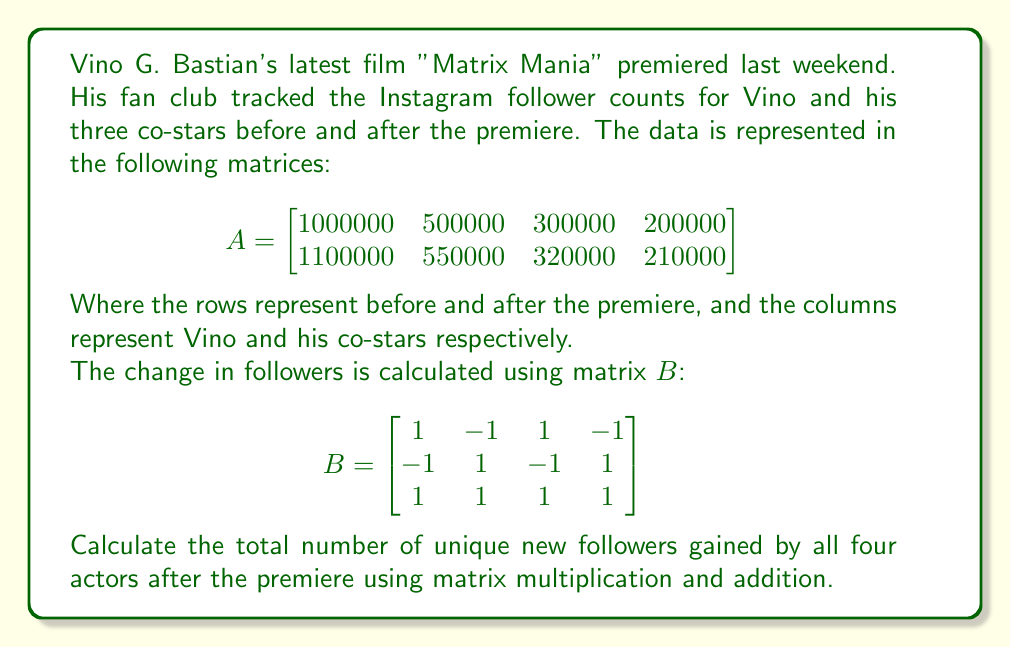Give your solution to this math problem. To solve this problem, we need to follow these steps:

1) First, we need to calculate the change in followers for each actor. We can do this by subtracting the "before" row from the "after" row in matrix $A$:

   $$C = \begin{bmatrix}
   1100000 - 1000000 & 550000 - 500000 & 320000 - 300000 & 210000 - 200000
   \end{bmatrix}$$

   $$C = \begin{bmatrix}
   100000 & 50000 & 20000 & 10000
   \end{bmatrix}$$

2) Now, we need to multiply matrix $C$ by matrix $B$. This operation will give us a 1x3 matrix:

   $$D = C \times B = \begin{bmatrix}
   100000 & 50000 & 20000 & 10000
   \end{bmatrix} \times \begin{bmatrix}
   1 & -1 & 1 \\
   -1 & 1 & -1 \\
   1 & -1 & 1 \\
   -1 & 1 & -1
   \end{bmatrix}$$

3) Performing this multiplication:

   $$D = \begin{bmatrix}
   (100000 - 50000 + 20000 - 10000) & (-100000 + 50000 - 20000 + 10000) & (100000 + 50000 + 20000 + 10000)
   \end{bmatrix}$$

   $$D = \begin{bmatrix}
   60000 & -60000 & 180000
   \end{bmatrix}$$

4) The last element in this matrix (180000) represents the total number of unique new followers gained by all four actors after the premiere.
Answer: The total number of unique new followers gained by Vino G. Bastian and his three co-stars after the premiere of "Matrix Mania" is 180,000. 